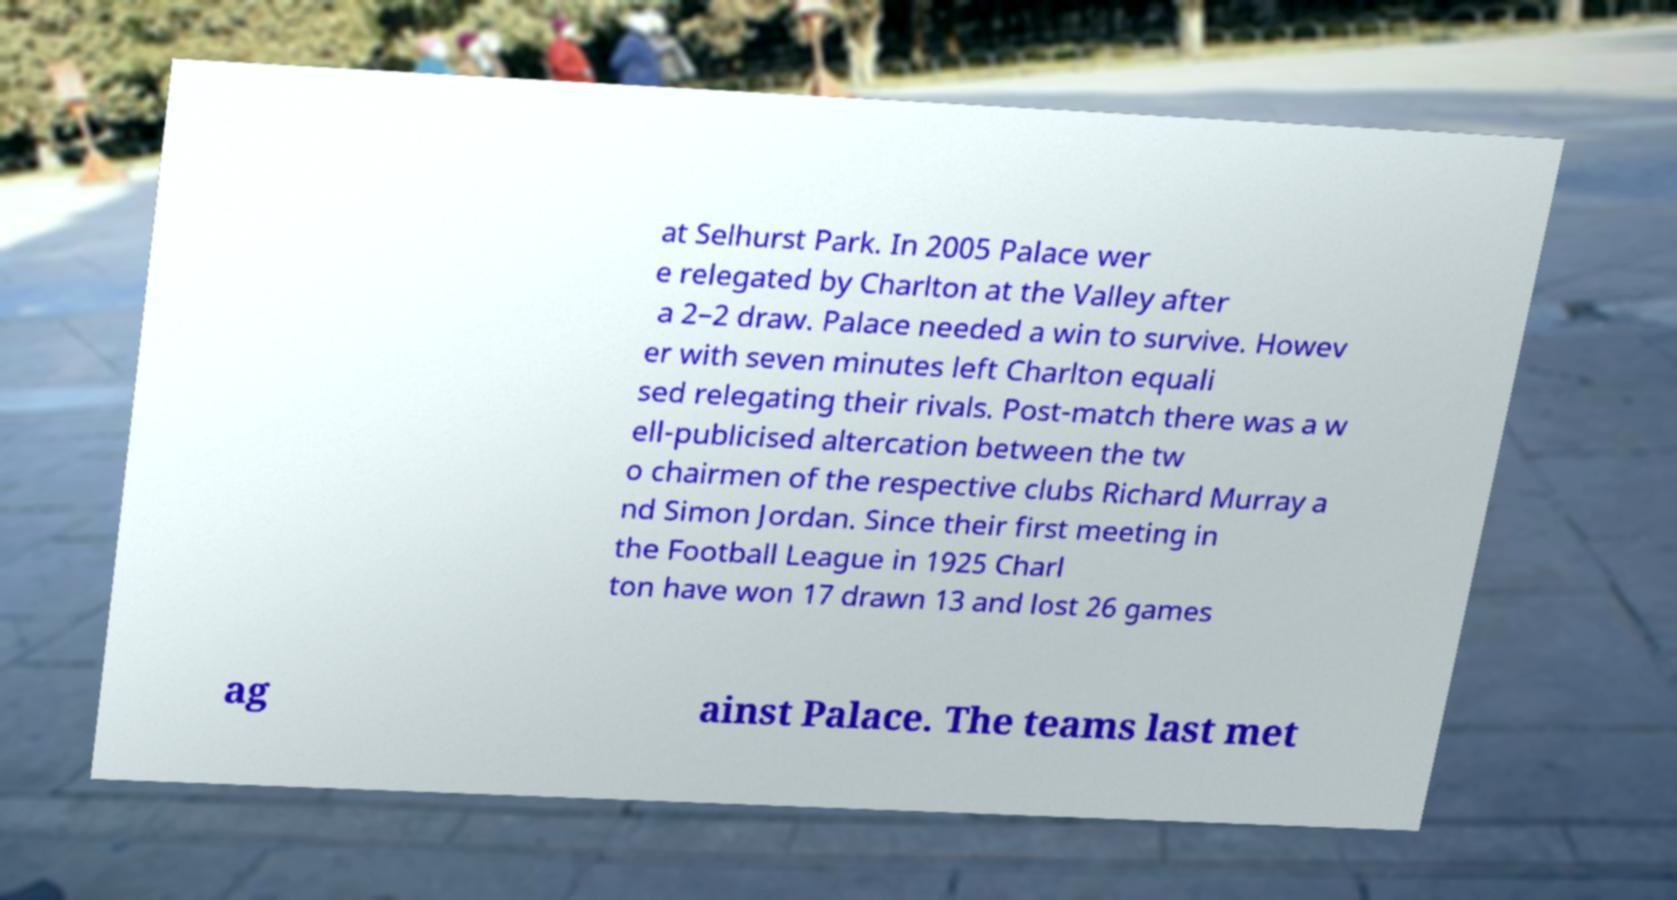What messages or text are displayed in this image? I need them in a readable, typed format. at Selhurst Park. In 2005 Palace wer e relegated by Charlton at the Valley after a 2–2 draw. Palace needed a win to survive. Howev er with seven minutes left Charlton equali sed relegating their rivals. Post-match there was a w ell-publicised altercation between the tw o chairmen of the respective clubs Richard Murray a nd Simon Jordan. Since their first meeting in the Football League in 1925 Charl ton have won 17 drawn 13 and lost 26 games ag ainst Palace. The teams last met 